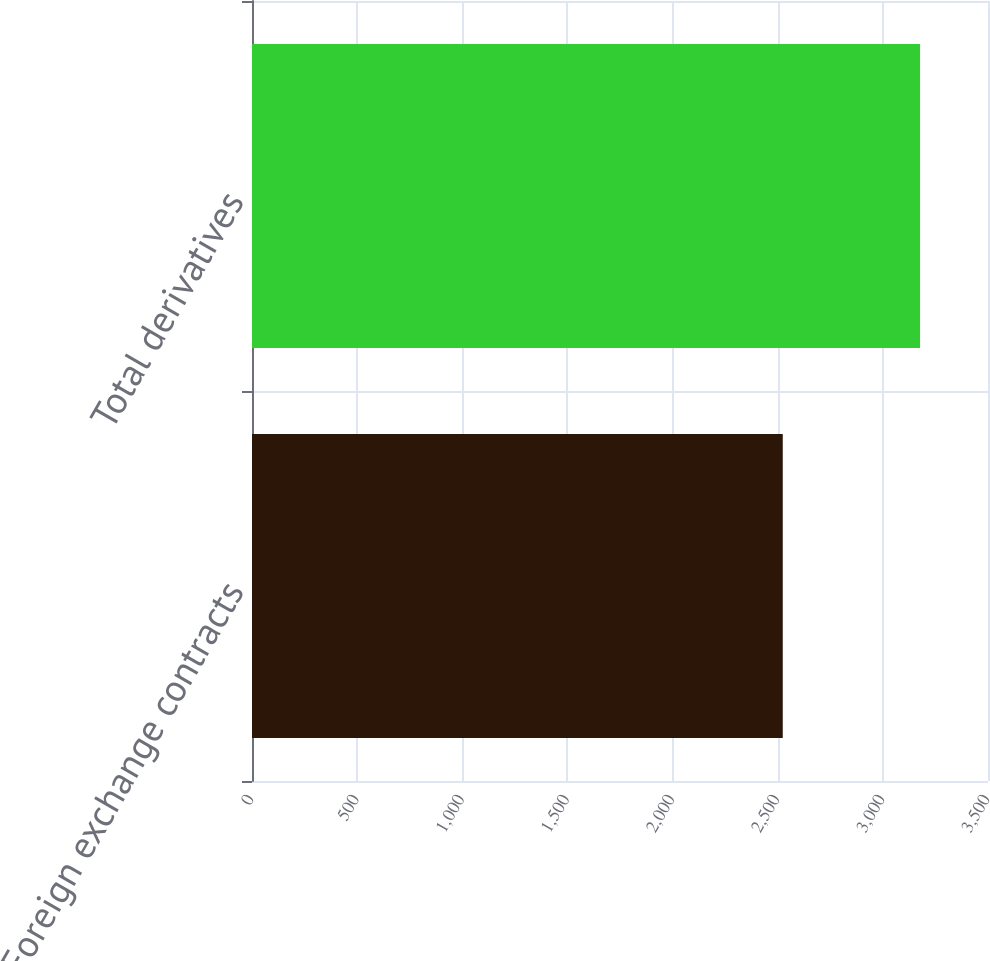<chart> <loc_0><loc_0><loc_500><loc_500><bar_chart><fcel>Foreign exchange contracts<fcel>Total derivatives<nl><fcel>2524<fcel>3177<nl></chart> 